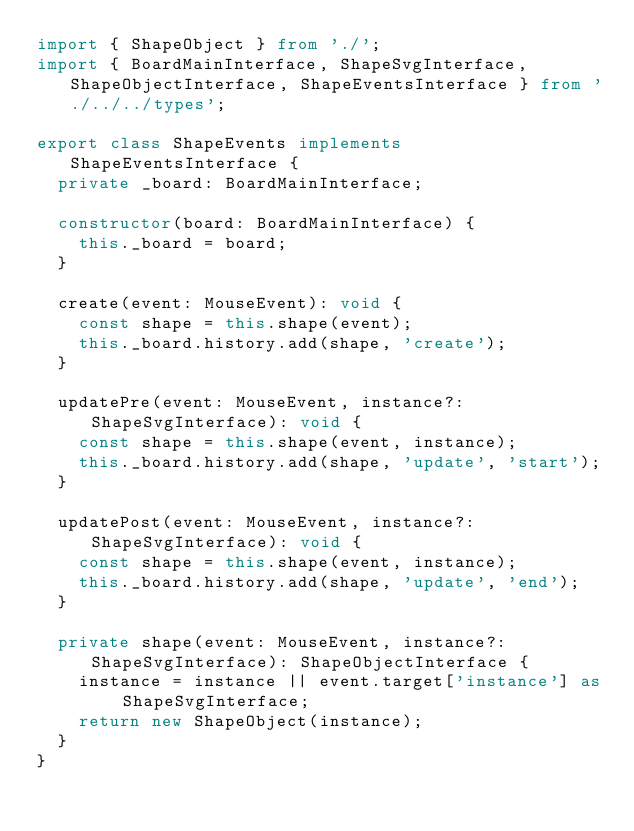Convert code to text. <code><loc_0><loc_0><loc_500><loc_500><_TypeScript_>import { ShapeObject } from './';
import { BoardMainInterface, ShapeSvgInterface, ShapeObjectInterface, ShapeEventsInterface } from './../../types';

export class ShapeEvents implements ShapeEventsInterface {
  private _board: BoardMainInterface;

  constructor(board: BoardMainInterface) {
    this._board = board;
  }

  create(event: MouseEvent): void {
    const shape = this.shape(event);
    this._board.history.add(shape, 'create');
  }

  updatePre(event: MouseEvent, instance?: ShapeSvgInterface): void {
    const shape = this.shape(event, instance);
    this._board.history.add(shape, 'update', 'start');
  }

  updatePost(event: MouseEvent, instance?: ShapeSvgInterface): void {
    const shape = this.shape(event, instance);
    this._board.history.add(shape, 'update', 'end');
  }

  private shape(event: MouseEvent, instance?: ShapeSvgInterface): ShapeObjectInterface {
    instance = instance || event.target['instance'] as ShapeSvgInterface;
    return new ShapeObject(instance);
  }
}
</code> 